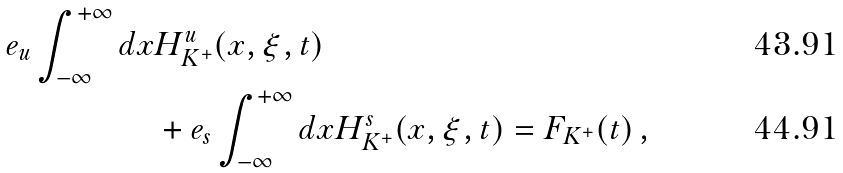<formula> <loc_0><loc_0><loc_500><loc_500>e _ { u } \int _ { - \infty } ^ { + \infty } d x & H _ { K ^ { + } } ^ { u } ( x , \xi , t ) \\ & + e _ { s } \int _ { - \infty } ^ { + \infty } d x H _ { K ^ { + } } ^ { s } ( x , \xi , t ) = F _ { K ^ { + } } ( t ) \, ,</formula> 